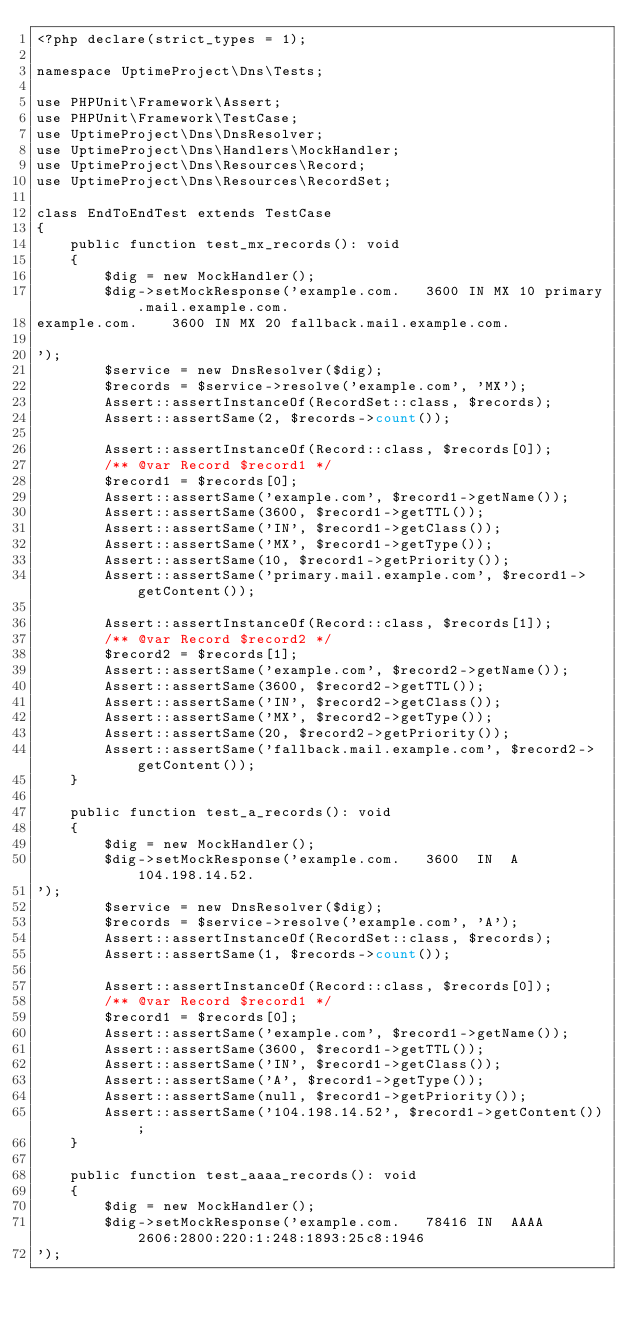<code> <loc_0><loc_0><loc_500><loc_500><_PHP_><?php declare(strict_types = 1);

namespace UptimeProject\Dns\Tests;

use PHPUnit\Framework\Assert;
use PHPUnit\Framework\TestCase;
use UptimeProject\Dns\DnsResolver;
use UptimeProject\Dns\Handlers\MockHandler;
use UptimeProject\Dns\Resources\Record;
use UptimeProject\Dns\Resources\RecordSet;

class EndToEndTest extends TestCase
{
    public function test_mx_records(): void
    {
        $dig = new MockHandler();
        $dig->setMockResponse('example.com.		3600 IN	MX 10 primary.mail.example.com.
example.com.		3600 IN	MX 20 fallback.mail.example.com.

');
        $service = new DnsResolver($dig);
        $records = $service->resolve('example.com', 'MX');
        Assert::assertInstanceOf(RecordSet::class, $records);
        Assert::assertSame(2, $records->count());

        Assert::assertInstanceOf(Record::class, $records[0]);
        /** @var Record $record1 */
        $record1 = $records[0];
        Assert::assertSame('example.com', $record1->getName());
        Assert::assertSame(3600, $record1->getTTL());
        Assert::assertSame('IN', $record1->getClass());
        Assert::assertSame('MX', $record1->getType());
        Assert::assertSame(10, $record1->getPriority());
        Assert::assertSame('primary.mail.example.com', $record1->getContent());

        Assert::assertInstanceOf(Record::class, $records[1]);
        /** @var Record $record2 */
        $record2 = $records[1];
        Assert::assertSame('example.com', $record2->getName());
        Assert::assertSame(3600, $record2->getTTL());
        Assert::assertSame('IN', $record2->getClass());
        Assert::assertSame('MX', $record2->getType());
        Assert::assertSame(20, $record2->getPriority());
        Assert::assertSame('fallback.mail.example.com', $record2->getContent());
    }

    public function test_a_records(): void
    {
        $dig = new MockHandler();
        $dig->setMockResponse('example.com.		3600	IN	A	104.198.14.52.
');
        $service = new DnsResolver($dig);
        $records = $service->resolve('example.com', 'A');
        Assert::assertInstanceOf(RecordSet::class, $records);
        Assert::assertSame(1, $records->count());

        Assert::assertInstanceOf(Record::class, $records[0]);
        /** @var Record $record1 */
        $record1 = $records[0];
        Assert::assertSame('example.com', $record1->getName());
        Assert::assertSame(3600, $record1->getTTL());
        Assert::assertSame('IN', $record1->getClass());
        Assert::assertSame('A', $record1->getType());
        Assert::assertSame(null, $record1->getPriority());
        Assert::assertSame('104.198.14.52', $record1->getContent());
    }

    public function test_aaaa_records(): void
    {
        $dig = new MockHandler();
        $dig->setMockResponse('example.com.		78416	IN	AAAA	2606:2800:220:1:248:1893:25c8:1946
');</code> 